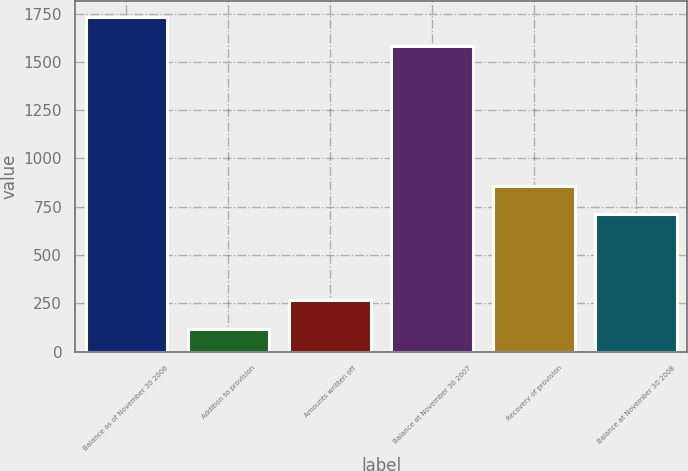Convert chart to OTSL. <chart><loc_0><loc_0><loc_500><loc_500><bar_chart><fcel>Balance as of November 30 2006<fcel>Addition to provision<fcel>Amounts written off<fcel>Balance at November 30 2007<fcel>Recovery of provision<fcel>Balance at November 30 2008<nl><fcel>1730.9<fcel>119<fcel>265.9<fcel>1584<fcel>858.9<fcel>712<nl></chart> 